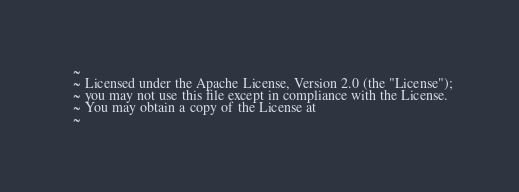Convert code to text. <code><loc_0><loc_0><loc_500><loc_500><_XML_>  ~
  ~ Licensed under the Apache License, Version 2.0 (the "License");
  ~ you may not use this file except in compliance with the License.
  ~ You may obtain a copy of the License at
  ~</code> 